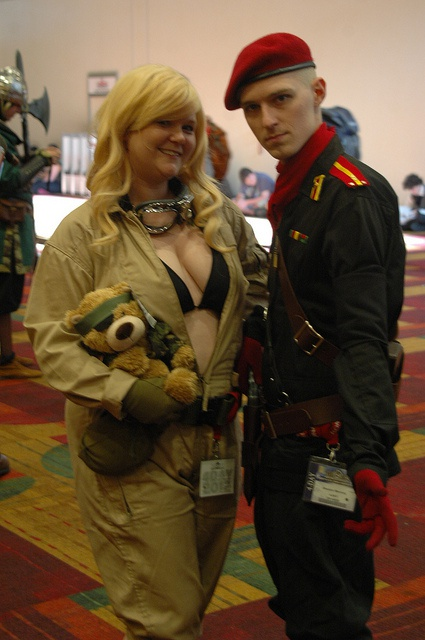Describe the objects in this image and their specific colors. I can see people in gray, black, olive, and maroon tones, teddy bear in gray, olive, black, and maroon tones, people in gray, black, darkgreen, and maroon tones, and people in gray, black, and darkgray tones in this image. 